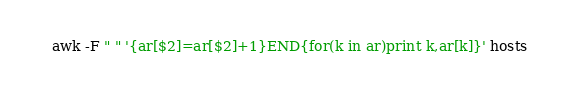Convert code to text. <code><loc_0><loc_0><loc_500><loc_500><_Awk_>awk -F " " '{ar[$2]=ar[$2]+1}END{for(k in ar)print k,ar[k]}' hosts 
</code> 